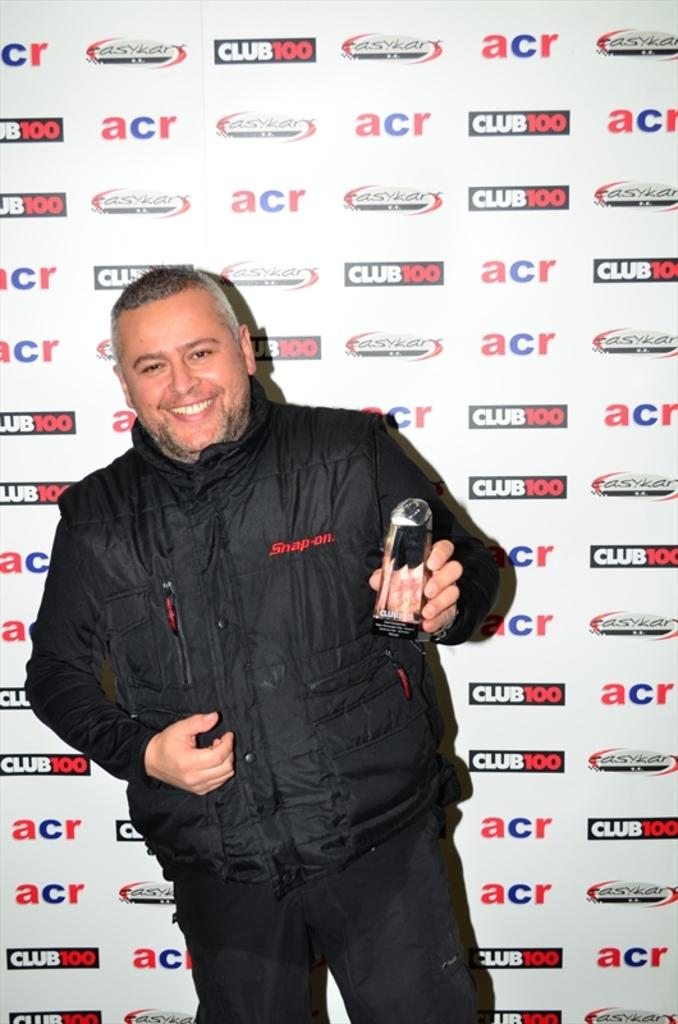What is the main subject of the image? There is a man in the image. What is the man doing in the image? The man is standing and smiling. What is the man holding in the image? The man is holding an object. What can be seen in the background of the image? There is a hoarding in the background of the image. What type of writer is the goldfish in the image? There is no goldfish present in the image, and therefore no writer can be identified. What type of party is the man attending in the image? There is no indication of a party in the image, and the man's actions do not suggest he is attending one. 